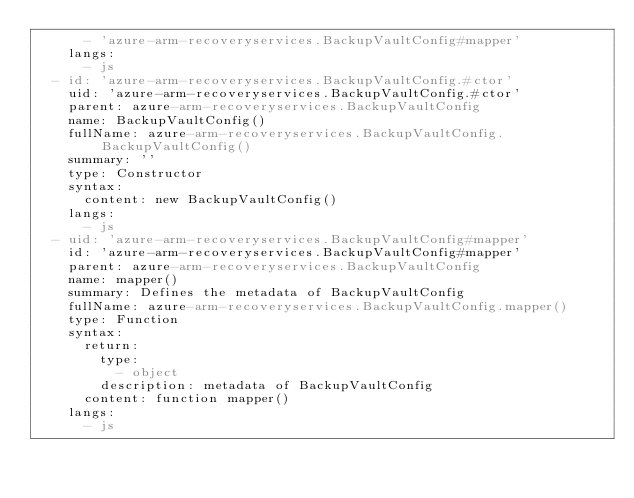<code> <loc_0><loc_0><loc_500><loc_500><_YAML_>      - 'azure-arm-recoveryservices.BackupVaultConfig#mapper'
    langs:
      - js
  - id: 'azure-arm-recoveryservices.BackupVaultConfig.#ctor'
    uid: 'azure-arm-recoveryservices.BackupVaultConfig.#ctor'
    parent: azure-arm-recoveryservices.BackupVaultConfig
    name: BackupVaultConfig()
    fullName: azure-arm-recoveryservices.BackupVaultConfig.BackupVaultConfig()
    summary: ''
    type: Constructor
    syntax:
      content: new BackupVaultConfig()
    langs:
      - js
  - uid: 'azure-arm-recoveryservices.BackupVaultConfig#mapper'
    id: 'azure-arm-recoveryservices.BackupVaultConfig#mapper'
    parent: azure-arm-recoveryservices.BackupVaultConfig
    name: mapper()
    summary: Defines the metadata of BackupVaultConfig
    fullName: azure-arm-recoveryservices.BackupVaultConfig.mapper()
    type: Function
    syntax:
      return:
        type:
          - object
        description: metadata of BackupVaultConfig
      content: function mapper()
    langs:
      - js
</code> 